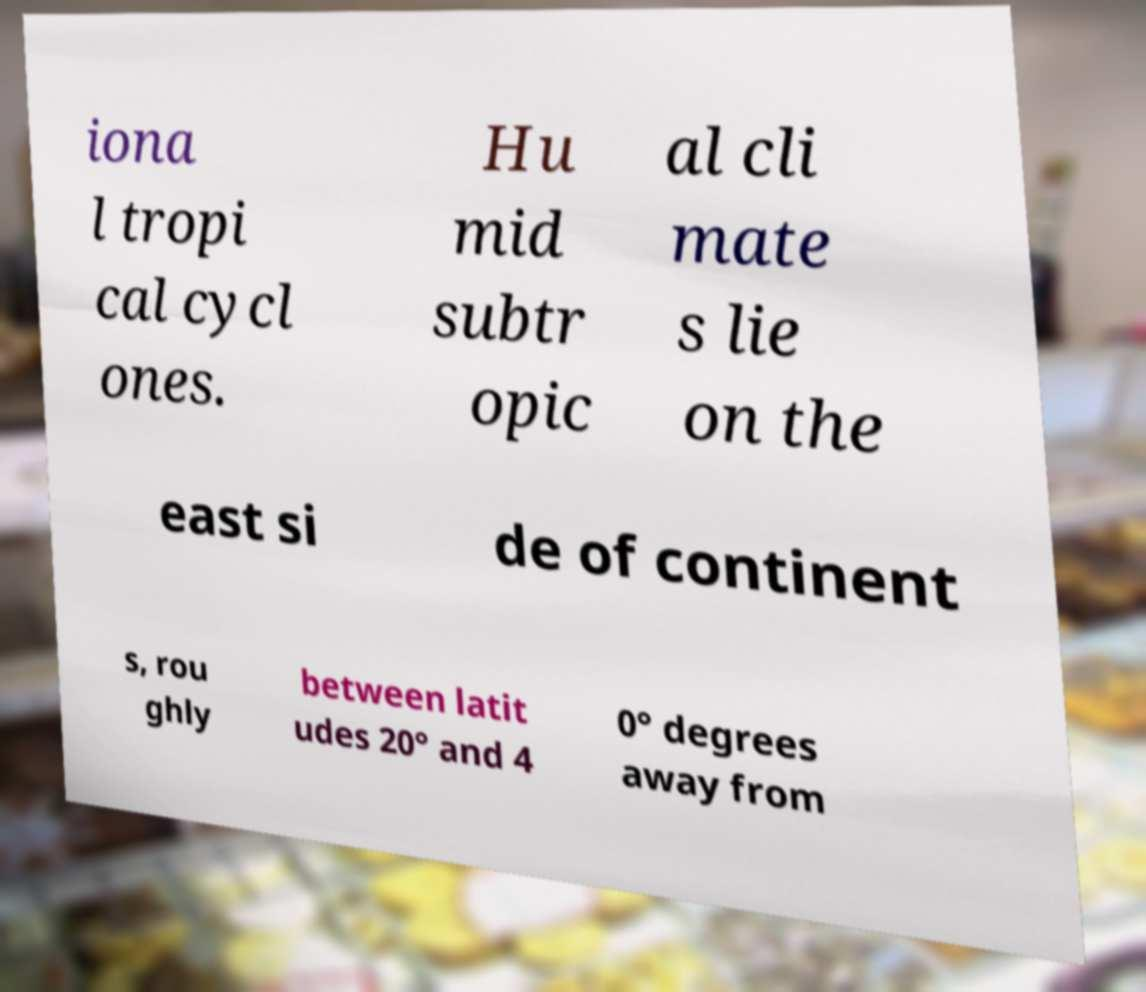Can you accurately transcribe the text from the provided image for me? iona l tropi cal cycl ones. Hu mid subtr opic al cli mate s lie on the east si de of continent s, rou ghly between latit udes 20° and 4 0° degrees away from 